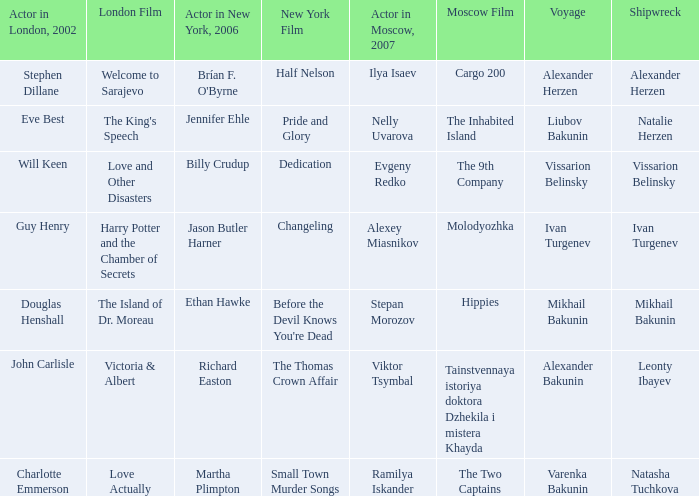In the 2006 new york production, who was the actor involved in the row with ramilya iskander, who performed in moscow in 2007? Martha Plimpton. 